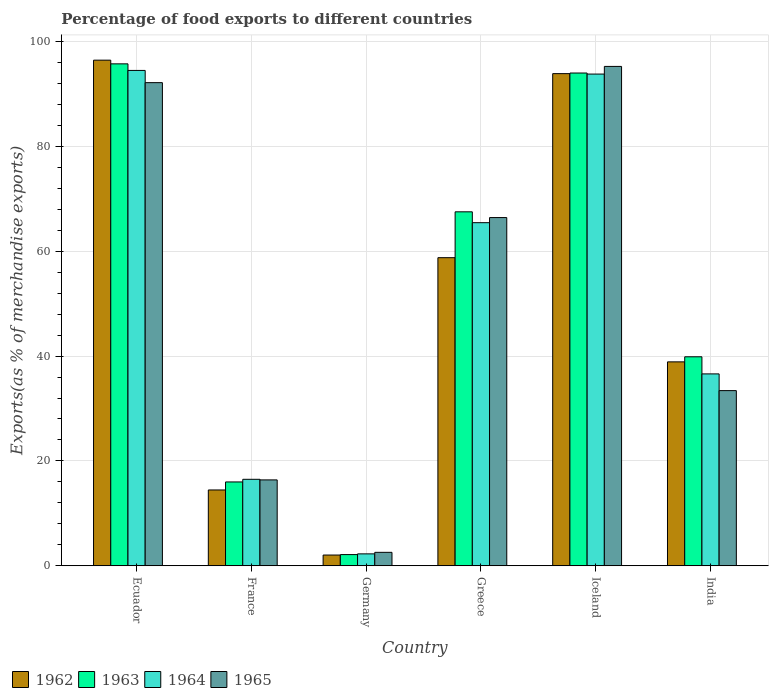Are the number of bars on each tick of the X-axis equal?
Give a very brief answer. Yes. How many bars are there on the 3rd tick from the right?
Offer a terse response. 4. What is the label of the 1st group of bars from the left?
Make the answer very short. Ecuador. What is the percentage of exports to different countries in 1962 in Ecuador?
Keep it short and to the point. 96.45. Across all countries, what is the maximum percentage of exports to different countries in 1963?
Provide a succinct answer. 95.74. Across all countries, what is the minimum percentage of exports to different countries in 1964?
Give a very brief answer. 2.27. In which country was the percentage of exports to different countries in 1963 maximum?
Give a very brief answer. Ecuador. In which country was the percentage of exports to different countries in 1963 minimum?
Provide a short and direct response. Germany. What is the total percentage of exports to different countries in 1965 in the graph?
Keep it short and to the point. 306.19. What is the difference between the percentage of exports to different countries in 1964 in Ecuador and that in India?
Your response must be concise. 57.88. What is the difference between the percentage of exports to different countries in 1964 in Ecuador and the percentage of exports to different countries in 1965 in Germany?
Keep it short and to the point. 91.92. What is the average percentage of exports to different countries in 1965 per country?
Offer a very short reply. 51.03. What is the difference between the percentage of exports to different countries of/in 1963 and percentage of exports to different countries of/in 1965 in India?
Ensure brevity in your answer.  6.45. In how many countries, is the percentage of exports to different countries in 1964 greater than 24 %?
Provide a succinct answer. 4. What is the ratio of the percentage of exports to different countries in 1962 in Ecuador to that in Greece?
Offer a terse response. 1.64. Is the difference between the percentage of exports to different countries in 1963 in France and Iceland greater than the difference between the percentage of exports to different countries in 1965 in France and Iceland?
Your answer should be compact. Yes. What is the difference between the highest and the second highest percentage of exports to different countries in 1965?
Your response must be concise. -25.73. What is the difference between the highest and the lowest percentage of exports to different countries in 1962?
Keep it short and to the point. 94.39. Is it the case that in every country, the sum of the percentage of exports to different countries in 1965 and percentage of exports to different countries in 1964 is greater than the sum of percentage of exports to different countries in 1962 and percentage of exports to different countries in 1963?
Your answer should be compact. No. How many bars are there?
Make the answer very short. 24. How many countries are there in the graph?
Your answer should be compact. 6. Where does the legend appear in the graph?
Give a very brief answer. Bottom left. How many legend labels are there?
Offer a very short reply. 4. How are the legend labels stacked?
Offer a terse response. Horizontal. What is the title of the graph?
Keep it short and to the point. Percentage of food exports to different countries. What is the label or title of the Y-axis?
Make the answer very short. Exports(as % of merchandise exports). What is the Exports(as % of merchandise exports) in 1962 in Ecuador?
Provide a succinct answer. 96.45. What is the Exports(as % of merchandise exports) of 1963 in Ecuador?
Your answer should be compact. 95.74. What is the Exports(as % of merchandise exports) in 1964 in Ecuador?
Offer a terse response. 94.49. What is the Exports(as % of merchandise exports) in 1965 in Ecuador?
Give a very brief answer. 92.15. What is the Exports(as % of merchandise exports) in 1962 in France?
Provide a short and direct response. 14.46. What is the Exports(as % of merchandise exports) of 1963 in France?
Offer a terse response. 15.99. What is the Exports(as % of merchandise exports) in 1964 in France?
Offer a very short reply. 16.5. What is the Exports(as % of merchandise exports) of 1965 in France?
Ensure brevity in your answer.  16.38. What is the Exports(as % of merchandise exports) in 1962 in Germany?
Ensure brevity in your answer.  2.05. What is the Exports(as % of merchandise exports) of 1963 in Germany?
Provide a succinct answer. 2.14. What is the Exports(as % of merchandise exports) in 1964 in Germany?
Provide a succinct answer. 2.27. What is the Exports(as % of merchandise exports) in 1965 in Germany?
Provide a succinct answer. 2.57. What is the Exports(as % of merchandise exports) of 1962 in Greece?
Ensure brevity in your answer.  58.77. What is the Exports(as % of merchandise exports) of 1963 in Greece?
Your answer should be compact. 67.52. What is the Exports(as % of merchandise exports) in 1964 in Greece?
Your answer should be very brief. 65.45. What is the Exports(as % of merchandise exports) of 1965 in Greece?
Offer a terse response. 66.42. What is the Exports(as % of merchandise exports) in 1962 in Iceland?
Offer a terse response. 93.87. What is the Exports(as % of merchandise exports) in 1963 in Iceland?
Keep it short and to the point. 93.99. What is the Exports(as % of merchandise exports) in 1964 in Iceland?
Provide a succinct answer. 93.79. What is the Exports(as % of merchandise exports) in 1965 in Iceland?
Your answer should be compact. 95.25. What is the Exports(as % of merchandise exports) of 1962 in India?
Give a very brief answer. 38.9. What is the Exports(as % of merchandise exports) in 1963 in India?
Offer a very short reply. 39.86. What is the Exports(as % of merchandise exports) in 1964 in India?
Give a very brief answer. 36.6. What is the Exports(as % of merchandise exports) of 1965 in India?
Give a very brief answer. 33.41. Across all countries, what is the maximum Exports(as % of merchandise exports) in 1962?
Ensure brevity in your answer.  96.45. Across all countries, what is the maximum Exports(as % of merchandise exports) of 1963?
Offer a terse response. 95.74. Across all countries, what is the maximum Exports(as % of merchandise exports) in 1964?
Offer a terse response. 94.49. Across all countries, what is the maximum Exports(as % of merchandise exports) of 1965?
Make the answer very short. 95.25. Across all countries, what is the minimum Exports(as % of merchandise exports) in 1962?
Provide a short and direct response. 2.05. Across all countries, what is the minimum Exports(as % of merchandise exports) in 1963?
Offer a terse response. 2.14. Across all countries, what is the minimum Exports(as % of merchandise exports) of 1964?
Keep it short and to the point. 2.27. Across all countries, what is the minimum Exports(as % of merchandise exports) in 1965?
Keep it short and to the point. 2.57. What is the total Exports(as % of merchandise exports) of 1962 in the graph?
Ensure brevity in your answer.  304.5. What is the total Exports(as % of merchandise exports) of 1963 in the graph?
Provide a short and direct response. 315.24. What is the total Exports(as % of merchandise exports) in 1964 in the graph?
Give a very brief answer. 309.1. What is the total Exports(as % of merchandise exports) in 1965 in the graph?
Provide a succinct answer. 306.19. What is the difference between the Exports(as % of merchandise exports) in 1962 in Ecuador and that in France?
Your response must be concise. 81.98. What is the difference between the Exports(as % of merchandise exports) in 1963 in Ecuador and that in France?
Offer a very short reply. 79.75. What is the difference between the Exports(as % of merchandise exports) in 1964 in Ecuador and that in France?
Your answer should be compact. 77.99. What is the difference between the Exports(as % of merchandise exports) in 1965 in Ecuador and that in France?
Your answer should be very brief. 75.77. What is the difference between the Exports(as % of merchandise exports) in 1962 in Ecuador and that in Germany?
Your response must be concise. 94.39. What is the difference between the Exports(as % of merchandise exports) in 1963 in Ecuador and that in Germany?
Make the answer very short. 93.6. What is the difference between the Exports(as % of merchandise exports) of 1964 in Ecuador and that in Germany?
Ensure brevity in your answer.  92.21. What is the difference between the Exports(as % of merchandise exports) in 1965 in Ecuador and that in Germany?
Your answer should be very brief. 89.59. What is the difference between the Exports(as % of merchandise exports) of 1962 in Ecuador and that in Greece?
Your answer should be compact. 37.67. What is the difference between the Exports(as % of merchandise exports) in 1963 in Ecuador and that in Greece?
Your response must be concise. 28.22. What is the difference between the Exports(as % of merchandise exports) in 1964 in Ecuador and that in Greece?
Offer a very short reply. 29.04. What is the difference between the Exports(as % of merchandise exports) of 1965 in Ecuador and that in Greece?
Offer a terse response. 25.73. What is the difference between the Exports(as % of merchandise exports) of 1962 in Ecuador and that in Iceland?
Offer a terse response. 2.57. What is the difference between the Exports(as % of merchandise exports) of 1963 in Ecuador and that in Iceland?
Keep it short and to the point. 1.75. What is the difference between the Exports(as % of merchandise exports) of 1964 in Ecuador and that in Iceland?
Make the answer very short. 0.7. What is the difference between the Exports(as % of merchandise exports) in 1965 in Ecuador and that in Iceland?
Your answer should be very brief. -3.1. What is the difference between the Exports(as % of merchandise exports) of 1962 in Ecuador and that in India?
Give a very brief answer. 57.55. What is the difference between the Exports(as % of merchandise exports) of 1963 in Ecuador and that in India?
Your response must be concise. 55.87. What is the difference between the Exports(as % of merchandise exports) in 1964 in Ecuador and that in India?
Provide a short and direct response. 57.88. What is the difference between the Exports(as % of merchandise exports) of 1965 in Ecuador and that in India?
Your response must be concise. 58.74. What is the difference between the Exports(as % of merchandise exports) in 1962 in France and that in Germany?
Provide a succinct answer. 12.41. What is the difference between the Exports(as % of merchandise exports) in 1963 in France and that in Germany?
Make the answer very short. 13.85. What is the difference between the Exports(as % of merchandise exports) of 1964 in France and that in Germany?
Keep it short and to the point. 14.22. What is the difference between the Exports(as % of merchandise exports) in 1965 in France and that in Germany?
Provide a short and direct response. 13.82. What is the difference between the Exports(as % of merchandise exports) in 1962 in France and that in Greece?
Make the answer very short. -44.31. What is the difference between the Exports(as % of merchandise exports) of 1963 in France and that in Greece?
Ensure brevity in your answer.  -51.53. What is the difference between the Exports(as % of merchandise exports) of 1964 in France and that in Greece?
Ensure brevity in your answer.  -48.95. What is the difference between the Exports(as % of merchandise exports) of 1965 in France and that in Greece?
Your answer should be very brief. -50.04. What is the difference between the Exports(as % of merchandise exports) of 1962 in France and that in Iceland?
Your answer should be very brief. -79.41. What is the difference between the Exports(as % of merchandise exports) in 1963 in France and that in Iceland?
Offer a very short reply. -78. What is the difference between the Exports(as % of merchandise exports) in 1964 in France and that in Iceland?
Give a very brief answer. -77.29. What is the difference between the Exports(as % of merchandise exports) in 1965 in France and that in Iceland?
Your answer should be very brief. -78.87. What is the difference between the Exports(as % of merchandise exports) of 1962 in France and that in India?
Your answer should be very brief. -24.43. What is the difference between the Exports(as % of merchandise exports) of 1963 in France and that in India?
Your response must be concise. -23.87. What is the difference between the Exports(as % of merchandise exports) in 1964 in France and that in India?
Your answer should be very brief. -20.11. What is the difference between the Exports(as % of merchandise exports) in 1965 in France and that in India?
Offer a very short reply. -17.03. What is the difference between the Exports(as % of merchandise exports) of 1962 in Germany and that in Greece?
Your answer should be compact. -56.72. What is the difference between the Exports(as % of merchandise exports) of 1963 in Germany and that in Greece?
Your answer should be compact. -65.38. What is the difference between the Exports(as % of merchandise exports) in 1964 in Germany and that in Greece?
Make the answer very short. -63.17. What is the difference between the Exports(as % of merchandise exports) of 1965 in Germany and that in Greece?
Provide a succinct answer. -63.85. What is the difference between the Exports(as % of merchandise exports) in 1962 in Germany and that in Iceland?
Give a very brief answer. -91.82. What is the difference between the Exports(as % of merchandise exports) of 1963 in Germany and that in Iceland?
Your answer should be very brief. -91.85. What is the difference between the Exports(as % of merchandise exports) in 1964 in Germany and that in Iceland?
Make the answer very short. -91.52. What is the difference between the Exports(as % of merchandise exports) of 1965 in Germany and that in Iceland?
Ensure brevity in your answer.  -92.68. What is the difference between the Exports(as % of merchandise exports) of 1962 in Germany and that in India?
Offer a very short reply. -36.84. What is the difference between the Exports(as % of merchandise exports) in 1963 in Germany and that in India?
Provide a short and direct response. -37.73. What is the difference between the Exports(as % of merchandise exports) of 1964 in Germany and that in India?
Offer a very short reply. -34.33. What is the difference between the Exports(as % of merchandise exports) in 1965 in Germany and that in India?
Keep it short and to the point. -30.85. What is the difference between the Exports(as % of merchandise exports) of 1962 in Greece and that in Iceland?
Provide a short and direct response. -35.1. What is the difference between the Exports(as % of merchandise exports) in 1963 in Greece and that in Iceland?
Your response must be concise. -26.47. What is the difference between the Exports(as % of merchandise exports) of 1964 in Greece and that in Iceland?
Your answer should be compact. -28.35. What is the difference between the Exports(as % of merchandise exports) in 1965 in Greece and that in Iceland?
Provide a succinct answer. -28.83. What is the difference between the Exports(as % of merchandise exports) in 1962 in Greece and that in India?
Make the answer very short. 19.87. What is the difference between the Exports(as % of merchandise exports) in 1963 in Greece and that in India?
Give a very brief answer. 27.65. What is the difference between the Exports(as % of merchandise exports) in 1964 in Greece and that in India?
Provide a succinct answer. 28.84. What is the difference between the Exports(as % of merchandise exports) of 1965 in Greece and that in India?
Your answer should be compact. 33.01. What is the difference between the Exports(as % of merchandise exports) of 1962 in Iceland and that in India?
Your response must be concise. 54.98. What is the difference between the Exports(as % of merchandise exports) in 1963 in Iceland and that in India?
Provide a short and direct response. 54.13. What is the difference between the Exports(as % of merchandise exports) of 1964 in Iceland and that in India?
Keep it short and to the point. 57.19. What is the difference between the Exports(as % of merchandise exports) of 1965 in Iceland and that in India?
Keep it short and to the point. 61.84. What is the difference between the Exports(as % of merchandise exports) of 1962 in Ecuador and the Exports(as % of merchandise exports) of 1963 in France?
Keep it short and to the point. 80.45. What is the difference between the Exports(as % of merchandise exports) in 1962 in Ecuador and the Exports(as % of merchandise exports) in 1964 in France?
Ensure brevity in your answer.  79.95. What is the difference between the Exports(as % of merchandise exports) in 1962 in Ecuador and the Exports(as % of merchandise exports) in 1965 in France?
Your answer should be very brief. 80.06. What is the difference between the Exports(as % of merchandise exports) of 1963 in Ecuador and the Exports(as % of merchandise exports) of 1964 in France?
Keep it short and to the point. 79.24. What is the difference between the Exports(as % of merchandise exports) in 1963 in Ecuador and the Exports(as % of merchandise exports) in 1965 in France?
Provide a short and direct response. 79.36. What is the difference between the Exports(as % of merchandise exports) in 1964 in Ecuador and the Exports(as % of merchandise exports) in 1965 in France?
Give a very brief answer. 78.1. What is the difference between the Exports(as % of merchandise exports) in 1962 in Ecuador and the Exports(as % of merchandise exports) in 1963 in Germany?
Provide a succinct answer. 94.31. What is the difference between the Exports(as % of merchandise exports) in 1962 in Ecuador and the Exports(as % of merchandise exports) in 1964 in Germany?
Your response must be concise. 94.17. What is the difference between the Exports(as % of merchandise exports) in 1962 in Ecuador and the Exports(as % of merchandise exports) in 1965 in Germany?
Offer a terse response. 93.88. What is the difference between the Exports(as % of merchandise exports) of 1963 in Ecuador and the Exports(as % of merchandise exports) of 1964 in Germany?
Keep it short and to the point. 93.46. What is the difference between the Exports(as % of merchandise exports) of 1963 in Ecuador and the Exports(as % of merchandise exports) of 1965 in Germany?
Give a very brief answer. 93.17. What is the difference between the Exports(as % of merchandise exports) of 1964 in Ecuador and the Exports(as % of merchandise exports) of 1965 in Germany?
Keep it short and to the point. 91.92. What is the difference between the Exports(as % of merchandise exports) in 1962 in Ecuador and the Exports(as % of merchandise exports) in 1963 in Greece?
Make the answer very short. 28.93. What is the difference between the Exports(as % of merchandise exports) in 1962 in Ecuador and the Exports(as % of merchandise exports) in 1964 in Greece?
Offer a terse response. 31. What is the difference between the Exports(as % of merchandise exports) of 1962 in Ecuador and the Exports(as % of merchandise exports) of 1965 in Greece?
Keep it short and to the point. 30.02. What is the difference between the Exports(as % of merchandise exports) of 1963 in Ecuador and the Exports(as % of merchandise exports) of 1964 in Greece?
Your answer should be very brief. 30.29. What is the difference between the Exports(as % of merchandise exports) in 1963 in Ecuador and the Exports(as % of merchandise exports) in 1965 in Greece?
Your answer should be compact. 29.32. What is the difference between the Exports(as % of merchandise exports) of 1964 in Ecuador and the Exports(as % of merchandise exports) of 1965 in Greece?
Ensure brevity in your answer.  28.07. What is the difference between the Exports(as % of merchandise exports) in 1962 in Ecuador and the Exports(as % of merchandise exports) in 1963 in Iceland?
Keep it short and to the point. 2.45. What is the difference between the Exports(as % of merchandise exports) in 1962 in Ecuador and the Exports(as % of merchandise exports) in 1964 in Iceland?
Provide a short and direct response. 2.65. What is the difference between the Exports(as % of merchandise exports) of 1962 in Ecuador and the Exports(as % of merchandise exports) of 1965 in Iceland?
Offer a terse response. 1.2. What is the difference between the Exports(as % of merchandise exports) in 1963 in Ecuador and the Exports(as % of merchandise exports) in 1964 in Iceland?
Offer a very short reply. 1.95. What is the difference between the Exports(as % of merchandise exports) in 1963 in Ecuador and the Exports(as % of merchandise exports) in 1965 in Iceland?
Make the answer very short. 0.49. What is the difference between the Exports(as % of merchandise exports) in 1964 in Ecuador and the Exports(as % of merchandise exports) in 1965 in Iceland?
Provide a short and direct response. -0.76. What is the difference between the Exports(as % of merchandise exports) of 1962 in Ecuador and the Exports(as % of merchandise exports) of 1963 in India?
Provide a short and direct response. 56.58. What is the difference between the Exports(as % of merchandise exports) of 1962 in Ecuador and the Exports(as % of merchandise exports) of 1964 in India?
Provide a short and direct response. 59.84. What is the difference between the Exports(as % of merchandise exports) of 1962 in Ecuador and the Exports(as % of merchandise exports) of 1965 in India?
Give a very brief answer. 63.03. What is the difference between the Exports(as % of merchandise exports) in 1963 in Ecuador and the Exports(as % of merchandise exports) in 1964 in India?
Your answer should be very brief. 59.14. What is the difference between the Exports(as % of merchandise exports) of 1963 in Ecuador and the Exports(as % of merchandise exports) of 1965 in India?
Make the answer very short. 62.33. What is the difference between the Exports(as % of merchandise exports) in 1964 in Ecuador and the Exports(as % of merchandise exports) in 1965 in India?
Your answer should be compact. 61.07. What is the difference between the Exports(as % of merchandise exports) in 1962 in France and the Exports(as % of merchandise exports) in 1963 in Germany?
Your answer should be compact. 12.32. What is the difference between the Exports(as % of merchandise exports) in 1962 in France and the Exports(as % of merchandise exports) in 1964 in Germany?
Keep it short and to the point. 12.19. What is the difference between the Exports(as % of merchandise exports) in 1962 in France and the Exports(as % of merchandise exports) in 1965 in Germany?
Ensure brevity in your answer.  11.9. What is the difference between the Exports(as % of merchandise exports) of 1963 in France and the Exports(as % of merchandise exports) of 1964 in Germany?
Keep it short and to the point. 13.72. What is the difference between the Exports(as % of merchandise exports) in 1963 in France and the Exports(as % of merchandise exports) in 1965 in Germany?
Provide a short and direct response. 13.42. What is the difference between the Exports(as % of merchandise exports) of 1964 in France and the Exports(as % of merchandise exports) of 1965 in Germany?
Your answer should be compact. 13.93. What is the difference between the Exports(as % of merchandise exports) of 1962 in France and the Exports(as % of merchandise exports) of 1963 in Greece?
Your response must be concise. -53.05. What is the difference between the Exports(as % of merchandise exports) of 1962 in France and the Exports(as % of merchandise exports) of 1964 in Greece?
Your response must be concise. -50.98. What is the difference between the Exports(as % of merchandise exports) of 1962 in France and the Exports(as % of merchandise exports) of 1965 in Greece?
Provide a short and direct response. -51.96. What is the difference between the Exports(as % of merchandise exports) in 1963 in France and the Exports(as % of merchandise exports) in 1964 in Greece?
Provide a short and direct response. -49.45. What is the difference between the Exports(as % of merchandise exports) of 1963 in France and the Exports(as % of merchandise exports) of 1965 in Greece?
Ensure brevity in your answer.  -50.43. What is the difference between the Exports(as % of merchandise exports) in 1964 in France and the Exports(as % of merchandise exports) in 1965 in Greece?
Keep it short and to the point. -49.93. What is the difference between the Exports(as % of merchandise exports) of 1962 in France and the Exports(as % of merchandise exports) of 1963 in Iceland?
Keep it short and to the point. -79.53. What is the difference between the Exports(as % of merchandise exports) in 1962 in France and the Exports(as % of merchandise exports) in 1964 in Iceland?
Your response must be concise. -79.33. What is the difference between the Exports(as % of merchandise exports) in 1962 in France and the Exports(as % of merchandise exports) in 1965 in Iceland?
Provide a succinct answer. -80.79. What is the difference between the Exports(as % of merchandise exports) of 1963 in France and the Exports(as % of merchandise exports) of 1964 in Iceland?
Your answer should be very brief. -77.8. What is the difference between the Exports(as % of merchandise exports) in 1963 in France and the Exports(as % of merchandise exports) in 1965 in Iceland?
Offer a terse response. -79.26. What is the difference between the Exports(as % of merchandise exports) of 1964 in France and the Exports(as % of merchandise exports) of 1965 in Iceland?
Make the answer very short. -78.75. What is the difference between the Exports(as % of merchandise exports) of 1962 in France and the Exports(as % of merchandise exports) of 1963 in India?
Your answer should be compact. -25.4. What is the difference between the Exports(as % of merchandise exports) of 1962 in France and the Exports(as % of merchandise exports) of 1964 in India?
Give a very brief answer. -22.14. What is the difference between the Exports(as % of merchandise exports) in 1962 in France and the Exports(as % of merchandise exports) in 1965 in India?
Give a very brief answer. -18.95. What is the difference between the Exports(as % of merchandise exports) in 1963 in France and the Exports(as % of merchandise exports) in 1964 in India?
Keep it short and to the point. -20.61. What is the difference between the Exports(as % of merchandise exports) of 1963 in France and the Exports(as % of merchandise exports) of 1965 in India?
Make the answer very short. -17.42. What is the difference between the Exports(as % of merchandise exports) in 1964 in France and the Exports(as % of merchandise exports) in 1965 in India?
Keep it short and to the point. -16.92. What is the difference between the Exports(as % of merchandise exports) in 1962 in Germany and the Exports(as % of merchandise exports) in 1963 in Greece?
Offer a terse response. -65.47. What is the difference between the Exports(as % of merchandise exports) of 1962 in Germany and the Exports(as % of merchandise exports) of 1964 in Greece?
Your answer should be very brief. -63.39. What is the difference between the Exports(as % of merchandise exports) in 1962 in Germany and the Exports(as % of merchandise exports) in 1965 in Greece?
Provide a short and direct response. -64.37. What is the difference between the Exports(as % of merchandise exports) in 1963 in Germany and the Exports(as % of merchandise exports) in 1964 in Greece?
Your answer should be very brief. -63.31. What is the difference between the Exports(as % of merchandise exports) in 1963 in Germany and the Exports(as % of merchandise exports) in 1965 in Greece?
Your answer should be very brief. -64.28. What is the difference between the Exports(as % of merchandise exports) in 1964 in Germany and the Exports(as % of merchandise exports) in 1965 in Greece?
Provide a succinct answer. -64.15. What is the difference between the Exports(as % of merchandise exports) in 1962 in Germany and the Exports(as % of merchandise exports) in 1963 in Iceland?
Ensure brevity in your answer.  -91.94. What is the difference between the Exports(as % of merchandise exports) of 1962 in Germany and the Exports(as % of merchandise exports) of 1964 in Iceland?
Give a very brief answer. -91.74. What is the difference between the Exports(as % of merchandise exports) in 1962 in Germany and the Exports(as % of merchandise exports) in 1965 in Iceland?
Keep it short and to the point. -93.2. What is the difference between the Exports(as % of merchandise exports) of 1963 in Germany and the Exports(as % of merchandise exports) of 1964 in Iceland?
Provide a succinct answer. -91.65. What is the difference between the Exports(as % of merchandise exports) of 1963 in Germany and the Exports(as % of merchandise exports) of 1965 in Iceland?
Your response must be concise. -93.11. What is the difference between the Exports(as % of merchandise exports) in 1964 in Germany and the Exports(as % of merchandise exports) in 1965 in Iceland?
Your answer should be very brief. -92.98. What is the difference between the Exports(as % of merchandise exports) of 1962 in Germany and the Exports(as % of merchandise exports) of 1963 in India?
Your response must be concise. -37.81. What is the difference between the Exports(as % of merchandise exports) of 1962 in Germany and the Exports(as % of merchandise exports) of 1964 in India?
Your answer should be very brief. -34.55. What is the difference between the Exports(as % of merchandise exports) in 1962 in Germany and the Exports(as % of merchandise exports) in 1965 in India?
Ensure brevity in your answer.  -31.36. What is the difference between the Exports(as % of merchandise exports) of 1963 in Germany and the Exports(as % of merchandise exports) of 1964 in India?
Your response must be concise. -34.46. What is the difference between the Exports(as % of merchandise exports) in 1963 in Germany and the Exports(as % of merchandise exports) in 1965 in India?
Provide a succinct answer. -31.27. What is the difference between the Exports(as % of merchandise exports) in 1964 in Germany and the Exports(as % of merchandise exports) in 1965 in India?
Provide a succinct answer. -31.14. What is the difference between the Exports(as % of merchandise exports) in 1962 in Greece and the Exports(as % of merchandise exports) in 1963 in Iceland?
Give a very brief answer. -35.22. What is the difference between the Exports(as % of merchandise exports) of 1962 in Greece and the Exports(as % of merchandise exports) of 1964 in Iceland?
Your response must be concise. -35.02. What is the difference between the Exports(as % of merchandise exports) in 1962 in Greece and the Exports(as % of merchandise exports) in 1965 in Iceland?
Offer a very short reply. -36.48. What is the difference between the Exports(as % of merchandise exports) in 1963 in Greece and the Exports(as % of merchandise exports) in 1964 in Iceland?
Give a very brief answer. -26.27. What is the difference between the Exports(as % of merchandise exports) in 1963 in Greece and the Exports(as % of merchandise exports) in 1965 in Iceland?
Provide a succinct answer. -27.73. What is the difference between the Exports(as % of merchandise exports) of 1964 in Greece and the Exports(as % of merchandise exports) of 1965 in Iceland?
Provide a succinct answer. -29.8. What is the difference between the Exports(as % of merchandise exports) of 1962 in Greece and the Exports(as % of merchandise exports) of 1963 in India?
Offer a terse response. 18.91. What is the difference between the Exports(as % of merchandise exports) of 1962 in Greece and the Exports(as % of merchandise exports) of 1964 in India?
Provide a succinct answer. 22.17. What is the difference between the Exports(as % of merchandise exports) in 1962 in Greece and the Exports(as % of merchandise exports) in 1965 in India?
Give a very brief answer. 25.36. What is the difference between the Exports(as % of merchandise exports) of 1963 in Greece and the Exports(as % of merchandise exports) of 1964 in India?
Keep it short and to the point. 30.92. What is the difference between the Exports(as % of merchandise exports) in 1963 in Greece and the Exports(as % of merchandise exports) in 1965 in India?
Provide a short and direct response. 34.1. What is the difference between the Exports(as % of merchandise exports) of 1964 in Greece and the Exports(as % of merchandise exports) of 1965 in India?
Offer a terse response. 32.03. What is the difference between the Exports(as % of merchandise exports) of 1962 in Iceland and the Exports(as % of merchandise exports) of 1963 in India?
Your answer should be very brief. 54.01. What is the difference between the Exports(as % of merchandise exports) in 1962 in Iceland and the Exports(as % of merchandise exports) in 1964 in India?
Provide a short and direct response. 57.27. What is the difference between the Exports(as % of merchandise exports) of 1962 in Iceland and the Exports(as % of merchandise exports) of 1965 in India?
Your response must be concise. 60.46. What is the difference between the Exports(as % of merchandise exports) in 1963 in Iceland and the Exports(as % of merchandise exports) in 1964 in India?
Offer a terse response. 57.39. What is the difference between the Exports(as % of merchandise exports) in 1963 in Iceland and the Exports(as % of merchandise exports) in 1965 in India?
Give a very brief answer. 60.58. What is the difference between the Exports(as % of merchandise exports) in 1964 in Iceland and the Exports(as % of merchandise exports) in 1965 in India?
Offer a very short reply. 60.38. What is the average Exports(as % of merchandise exports) in 1962 per country?
Provide a succinct answer. 50.75. What is the average Exports(as % of merchandise exports) in 1963 per country?
Your answer should be compact. 52.54. What is the average Exports(as % of merchandise exports) of 1964 per country?
Offer a terse response. 51.52. What is the average Exports(as % of merchandise exports) in 1965 per country?
Your answer should be compact. 51.03. What is the difference between the Exports(as % of merchandise exports) in 1962 and Exports(as % of merchandise exports) in 1963 in Ecuador?
Provide a succinct answer. 0.71. What is the difference between the Exports(as % of merchandise exports) in 1962 and Exports(as % of merchandise exports) in 1964 in Ecuador?
Provide a succinct answer. 1.96. What is the difference between the Exports(as % of merchandise exports) of 1962 and Exports(as % of merchandise exports) of 1965 in Ecuador?
Provide a short and direct response. 4.29. What is the difference between the Exports(as % of merchandise exports) of 1963 and Exports(as % of merchandise exports) of 1964 in Ecuador?
Keep it short and to the point. 1.25. What is the difference between the Exports(as % of merchandise exports) in 1963 and Exports(as % of merchandise exports) in 1965 in Ecuador?
Offer a very short reply. 3.58. What is the difference between the Exports(as % of merchandise exports) in 1964 and Exports(as % of merchandise exports) in 1965 in Ecuador?
Offer a terse response. 2.33. What is the difference between the Exports(as % of merchandise exports) of 1962 and Exports(as % of merchandise exports) of 1963 in France?
Give a very brief answer. -1.53. What is the difference between the Exports(as % of merchandise exports) in 1962 and Exports(as % of merchandise exports) in 1964 in France?
Your response must be concise. -2.03. What is the difference between the Exports(as % of merchandise exports) of 1962 and Exports(as % of merchandise exports) of 1965 in France?
Make the answer very short. -1.92. What is the difference between the Exports(as % of merchandise exports) in 1963 and Exports(as % of merchandise exports) in 1964 in France?
Your response must be concise. -0.5. What is the difference between the Exports(as % of merchandise exports) of 1963 and Exports(as % of merchandise exports) of 1965 in France?
Your answer should be very brief. -0.39. What is the difference between the Exports(as % of merchandise exports) in 1964 and Exports(as % of merchandise exports) in 1965 in France?
Give a very brief answer. 0.11. What is the difference between the Exports(as % of merchandise exports) in 1962 and Exports(as % of merchandise exports) in 1963 in Germany?
Offer a very short reply. -0.09. What is the difference between the Exports(as % of merchandise exports) of 1962 and Exports(as % of merchandise exports) of 1964 in Germany?
Provide a short and direct response. -0.22. What is the difference between the Exports(as % of merchandise exports) of 1962 and Exports(as % of merchandise exports) of 1965 in Germany?
Make the answer very short. -0.52. What is the difference between the Exports(as % of merchandise exports) of 1963 and Exports(as % of merchandise exports) of 1964 in Germany?
Provide a short and direct response. -0.14. What is the difference between the Exports(as % of merchandise exports) of 1963 and Exports(as % of merchandise exports) of 1965 in Germany?
Your answer should be very brief. -0.43. What is the difference between the Exports(as % of merchandise exports) of 1964 and Exports(as % of merchandise exports) of 1965 in Germany?
Provide a short and direct response. -0.29. What is the difference between the Exports(as % of merchandise exports) in 1962 and Exports(as % of merchandise exports) in 1963 in Greece?
Your answer should be compact. -8.75. What is the difference between the Exports(as % of merchandise exports) in 1962 and Exports(as % of merchandise exports) in 1964 in Greece?
Your answer should be compact. -6.67. What is the difference between the Exports(as % of merchandise exports) in 1962 and Exports(as % of merchandise exports) in 1965 in Greece?
Offer a very short reply. -7.65. What is the difference between the Exports(as % of merchandise exports) of 1963 and Exports(as % of merchandise exports) of 1964 in Greece?
Provide a short and direct response. 2.07. What is the difference between the Exports(as % of merchandise exports) of 1963 and Exports(as % of merchandise exports) of 1965 in Greece?
Provide a succinct answer. 1.1. What is the difference between the Exports(as % of merchandise exports) in 1964 and Exports(as % of merchandise exports) in 1965 in Greece?
Offer a very short reply. -0.98. What is the difference between the Exports(as % of merchandise exports) in 1962 and Exports(as % of merchandise exports) in 1963 in Iceland?
Keep it short and to the point. -0.12. What is the difference between the Exports(as % of merchandise exports) of 1962 and Exports(as % of merchandise exports) of 1964 in Iceland?
Offer a very short reply. 0.08. What is the difference between the Exports(as % of merchandise exports) of 1962 and Exports(as % of merchandise exports) of 1965 in Iceland?
Your answer should be very brief. -1.38. What is the difference between the Exports(as % of merchandise exports) in 1963 and Exports(as % of merchandise exports) in 1965 in Iceland?
Keep it short and to the point. -1.26. What is the difference between the Exports(as % of merchandise exports) in 1964 and Exports(as % of merchandise exports) in 1965 in Iceland?
Give a very brief answer. -1.46. What is the difference between the Exports(as % of merchandise exports) in 1962 and Exports(as % of merchandise exports) in 1963 in India?
Offer a very short reply. -0.97. What is the difference between the Exports(as % of merchandise exports) of 1962 and Exports(as % of merchandise exports) of 1964 in India?
Your response must be concise. 2.29. What is the difference between the Exports(as % of merchandise exports) of 1962 and Exports(as % of merchandise exports) of 1965 in India?
Offer a very short reply. 5.48. What is the difference between the Exports(as % of merchandise exports) of 1963 and Exports(as % of merchandise exports) of 1964 in India?
Offer a very short reply. 3.26. What is the difference between the Exports(as % of merchandise exports) of 1963 and Exports(as % of merchandise exports) of 1965 in India?
Provide a succinct answer. 6.45. What is the difference between the Exports(as % of merchandise exports) in 1964 and Exports(as % of merchandise exports) in 1965 in India?
Keep it short and to the point. 3.19. What is the ratio of the Exports(as % of merchandise exports) of 1962 in Ecuador to that in France?
Your answer should be compact. 6.67. What is the ratio of the Exports(as % of merchandise exports) of 1963 in Ecuador to that in France?
Give a very brief answer. 5.99. What is the ratio of the Exports(as % of merchandise exports) of 1964 in Ecuador to that in France?
Ensure brevity in your answer.  5.73. What is the ratio of the Exports(as % of merchandise exports) of 1965 in Ecuador to that in France?
Keep it short and to the point. 5.62. What is the ratio of the Exports(as % of merchandise exports) of 1962 in Ecuador to that in Germany?
Offer a very short reply. 47.01. What is the ratio of the Exports(as % of merchandise exports) in 1963 in Ecuador to that in Germany?
Keep it short and to the point. 44.76. What is the ratio of the Exports(as % of merchandise exports) of 1964 in Ecuador to that in Germany?
Provide a short and direct response. 41.54. What is the ratio of the Exports(as % of merchandise exports) in 1965 in Ecuador to that in Germany?
Offer a very short reply. 35.89. What is the ratio of the Exports(as % of merchandise exports) of 1962 in Ecuador to that in Greece?
Provide a succinct answer. 1.64. What is the ratio of the Exports(as % of merchandise exports) of 1963 in Ecuador to that in Greece?
Give a very brief answer. 1.42. What is the ratio of the Exports(as % of merchandise exports) of 1964 in Ecuador to that in Greece?
Provide a short and direct response. 1.44. What is the ratio of the Exports(as % of merchandise exports) of 1965 in Ecuador to that in Greece?
Give a very brief answer. 1.39. What is the ratio of the Exports(as % of merchandise exports) of 1962 in Ecuador to that in Iceland?
Keep it short and to the point. 1.03. What is the ratio of the Exports(as % of merchandise exports) of 1963 in Ecuador to that in Iceland?
Ensure brevity in your answer.  1.02. What is the ratio of the Exports(as % of merchandise exports) of 1964 in Ecuador to that in Iceland?
Your response must be concise. 1.01. What is the ratio of the Exports(as % of merchandise exports) of 1965 in Ecuador to that in Iceland?
Give a very brief answer. 0.97. What is the ratio of the Exports(as % of merchandise exports) of 1962 in Ecuador to that in India?
Your answer should be very brief. 2.48. What is the ratio of the Exports(as % of merchandise exports) in 1963 in Ecuador to that in India?
Offer a terse response. 2.4. What is the ratio of the Exports(as % of merchandise exports) of 1964 in Ecuador to that in India?
Your answer should be compact. 2.58. What is the ratio of the Exports(as % of merchandise exports) of 1965 in Ecuador to that in India?
Offer a terse response. 2.76. What is the ratio of the Exports(as % of merchandise exports) of 1962 in France to that in Germany?
Provide a short and direct response. 7.05. What is the ratio of the Exports(as % of merchandise exports) in 1963 in France to that in Germany?
Provide a short and direct response. 7.48. What is the ratio of the Exports(as % of merchandise exports) in 1964 in France to that in Germany?
Your answer should be compact. 7.25. What is the ratio of the Exports(as % of merchandise exports) of 1965 in France to that in Germany?
Provide a short and direct response. 6.38. What is the ratio of the Exports(as % of merchandise exports) of 1962 in France to that in Greece?
Your response must be concise. 0.25. What is the ratio of the Exports(as % of merchandise exports) of 1963 in France to that in Greece?
Keep it short and to the point. 0.24. What is the ratio of the Exports(as % of merchandise exports) of 1964 in France to that in Greece?
Give a very brief answer. 0.25. What is the ratio of the Exports(as % of merchandise exports) in 1965 in France to that in Greece?
Offer a very short reply. 0.25. What is the ratio of the Exports(as % of merchandise exports) of 1962 in France to that in Iceland?
Provide a succinct answer. 0.15. What is the ratio of the Exports(as % of merchandise exports) in 1963 in France to that in Iceland?
Offer a terse response. 0.17. What is the ratio of the Exports(as % of merchandise exports) in 1964 in France to that in Iceland?
Offer a terse response. 0.18. What is the ratio of the Exports(as % of merchandise exports) in 1965 in France to that in Iceland?
Offer a terse response. 0.17. What is the ratio of the Exports(as % of merchandise exports) in 1962 in France to that in India?
Your response must be concise. 0.37. What is the ratio of the Exports(as % of merchandise exports) of 1963 in France to that in India?
Your response must be concise. 0.4. What is the ratio of the Exports(as % of merchandise exports) in 1964 in France to that in India?
Offer a very short reply. 0.45. What is the ratio of the Exports(as % of merchandise exports) of 1965 in France to that in India?
Provide a short and direct response. 0.49. What is the ratio of the Exports(as % of merchandise exports) of 1962 in Germany to that in Greece?
Provide a succinct answer. 0.03. What is the ratio of the Exports(as % of merchandise exports) of 1963 in Germany to that in Greece?
Offer a very short reply. 0.03. What is the ratio of the Exports(as % of merchandise exports) in 1964 in Germany to that in Greece?
Keep it short and to the point. 0.03. What is the ratio of the Exports(as % of merchandise exports) of 1965 in Germany to that in Greece?
Give a very brief answer. 0.04. What is the ratio of the Exports(as % of merchandise exports) of 1962 in Germany to that in Iceland?
Keep it short and to the point. 0.02. What is the ratio of the Exports(as % of merchandise exports) in 1963 in Germany to that in Iceland?
Provide a succinct answer. 0.02. What is the ratio of the Exports(as % of merchandise exports) in 1964 in Germany to that in Iceland?
Give a very brief answer. 0.02. What is the ratio of the Exports(as % of merchandise exports) of 1965 in Germany to that in Iceland?
Ensure brevity in your answer.  0.03. What is the ratio of the Exports(as % of merchandise exports) of 1962 in Germany to that in India?
Your answer should be very brief. 0.05. What is the ratio of the Exports(as % of merchandise exports) of 1963 in Germany to that in India?
Give a very brief answer. 0.05. What is the ratio of the Exports(as % of merchandise exports) of 1964 in Germany to that in India?
Give a very brief answer. 0.06. What is the ratio of the Exports(as % of merchandise exports) in 1965 in Germany to that in India?
Your answer should be very brief. 0.08. What is the ratio of the Exports(as % of merchandise exports) of 1962 in Greece to that in Iceland?
Ensure brevity in your answer.  0.63. What is the ratio of the Exports(as % of merchandise exports) in 1963 in Greece to that in Iceland?
Give a very brief answer. 0.72. What is the ratio of the Exports(as % of merchandise exports) of 1964 in Greece to that in Iceland?
Give a very brief answer. 0.7. What is the ratio of the Exports(as % of merchandise exports) in 1965 in Greece to that in Iceland?
Keep it short and to the point. 0.7. What is the ratio of the Exports(as % of merchandise exports) of 1962 in Greece to that in India?
Offer a terse response. 1.51. What is the ratio of the Exports(as % of merchandise exports) of 1963 in Greece to that in India?
Offer a terse response. 1.69. What is the ratio of the Exports(as % of merchandise exports) of 1964 in Greece to that in India?
Ensure brevity in your answer.  1.79. What is the ratio of the Exports(as % of merchandise exports) of 1965 in Greece to that in India?
Your response must be concise. 1.99. What is the ratio of the Exports(as % of merchandise exports) of 1962 in Iceland to that in India?
Provide a succinct answer. 2.41. What is the ratio of the Exports(as % of merchandise exports) of 1963 in Iceland to that in India?
Ensure brevity in your answer.  2.36. What is the ratio of the Exports(as % of merchandise exports) in 1964 in Iceland to that in India?
Give a very brief answer. 2.56. What is the ratio of the Exports(as % of merchandise exports) of 1965 in Iceland to that in India?
Offer a terse response. 2.85. What is the difference between the highest and the second highest Exports(as % of merchandise exports) in 1962?
Your response must be concise. 2.57. What is the difference between the highest and the second highest Exports(as % of merchandise exports) in 1963?
Ensure brevity in your answer.  1.75. What is the difference between the highest and the second highest Exports(as % of merchandise exports) in 1964?
Make the answer very short. 0.7. What is the difference between the highest and the second highest Exports(as % of merchandise exports) of 1965?
Offer a terse response. 3.1. What is the difference between the highest and the lowest Exports(as % of merchandise exports) of 1962?
Make the answer very short. 94.39. What is the difference between the highest and the lowest Exports(as % of merchandise exports) in 1963?
Offer a very short reply. 93.6. What is the difference between the highest and the lowest Exports(as % of merchandise exports) of 1964?
Your response must be concise. 92.21. What is the difference between the highest and the lowest Exports(as % of merchandise exports) in 1965?
Your answer should be very brief. 92.68. 